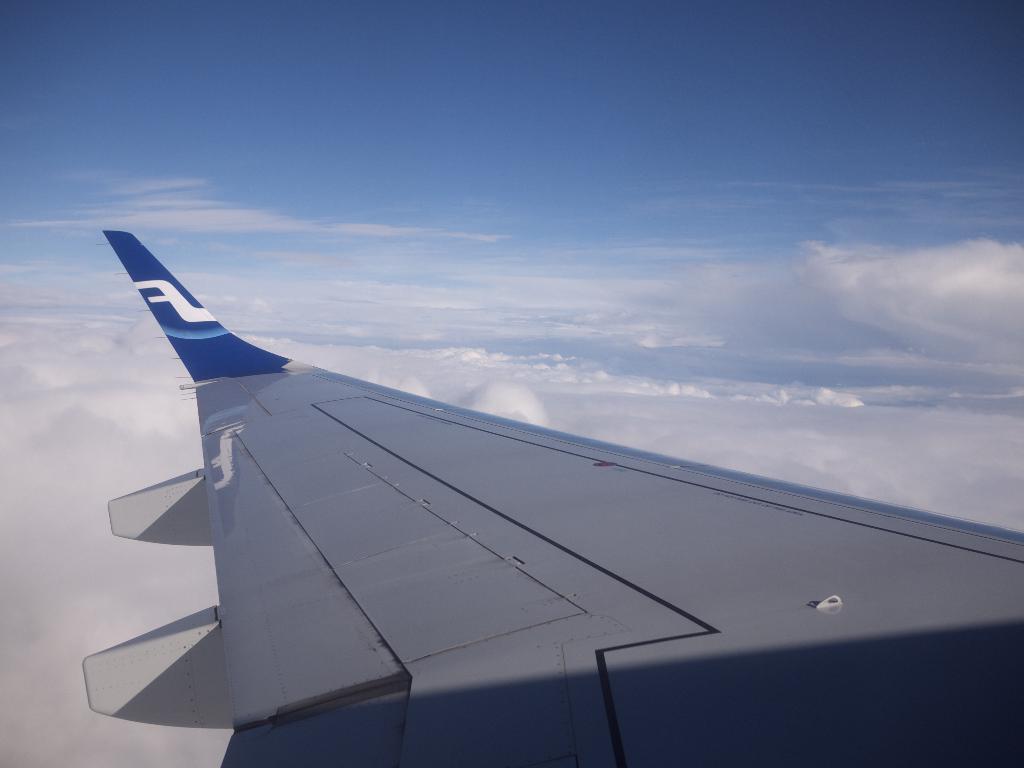Describe this image in one or two sentences. In this image we can see an airplane wing which is in blue and white color and in the background of the image there are some clouds and clear sky. 